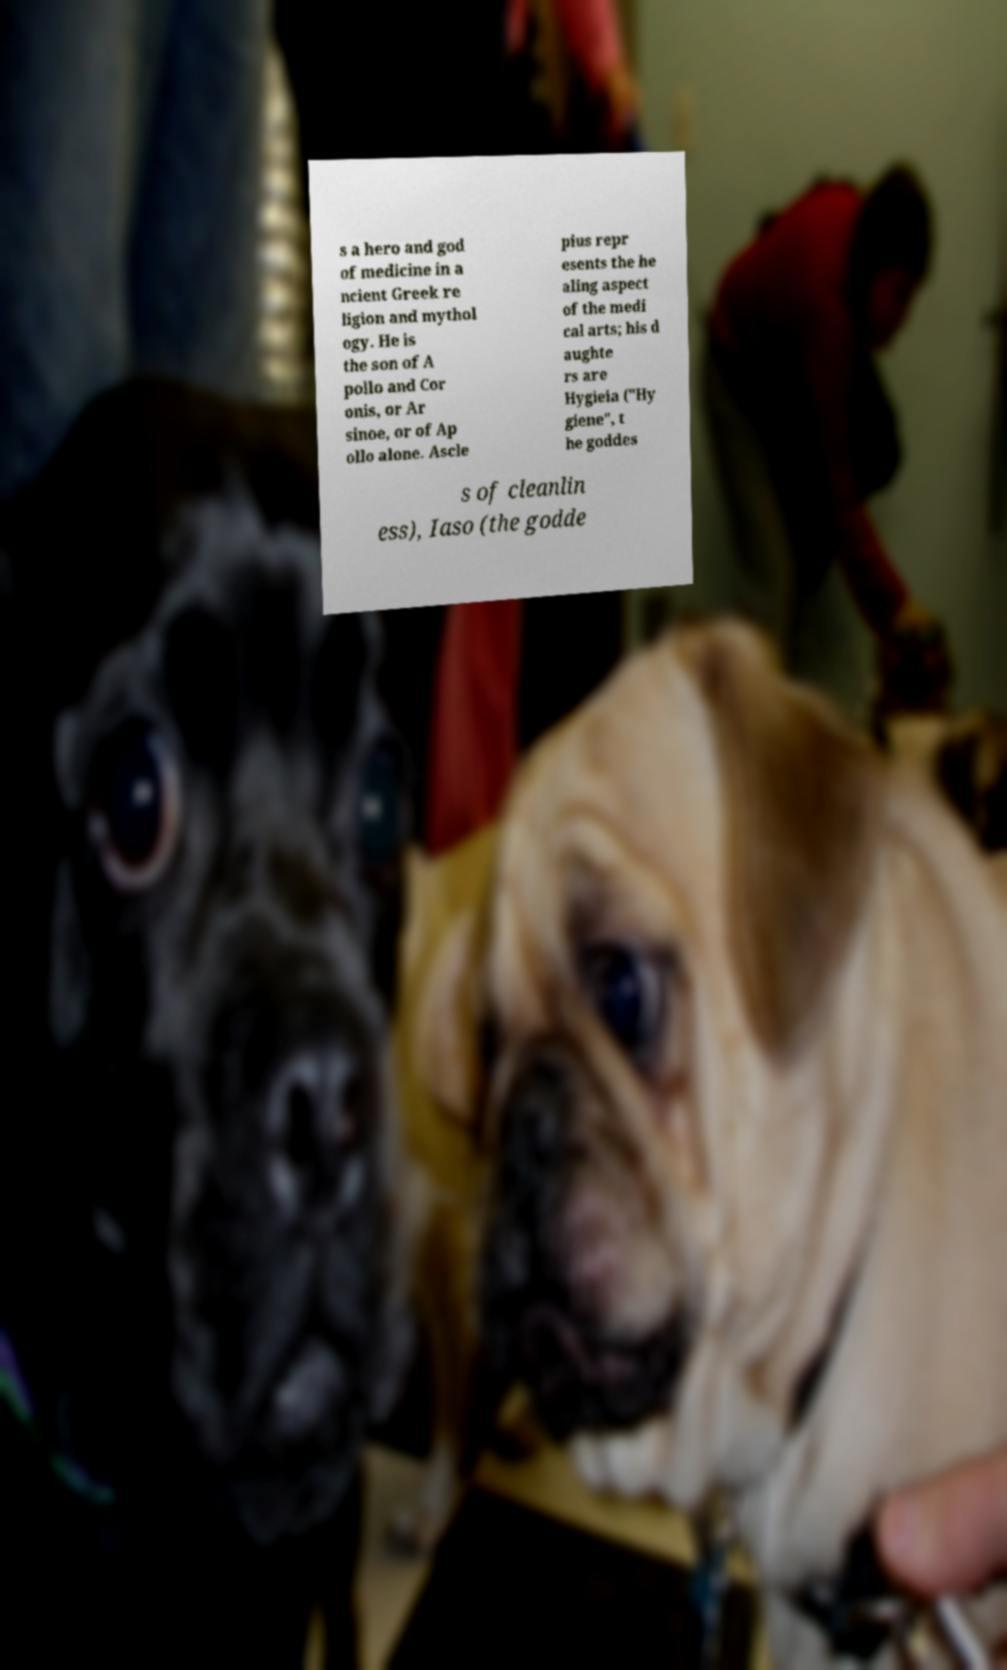What messages or text are displayed in this image? I need them in a readable, typed format. s a hero and god of medicine in a ncient Greek re ligion and mythol ogy. He is the son of A pollo and Cor onis, or Ar sinoe, or of Ap ollo alone. Ascle pius repr esents the he aling aspect of the medi cal arts; his d aughte rs are Hygieia ("Hy giene", t he goddes s of cleanlin ess), Iaso (the godde 